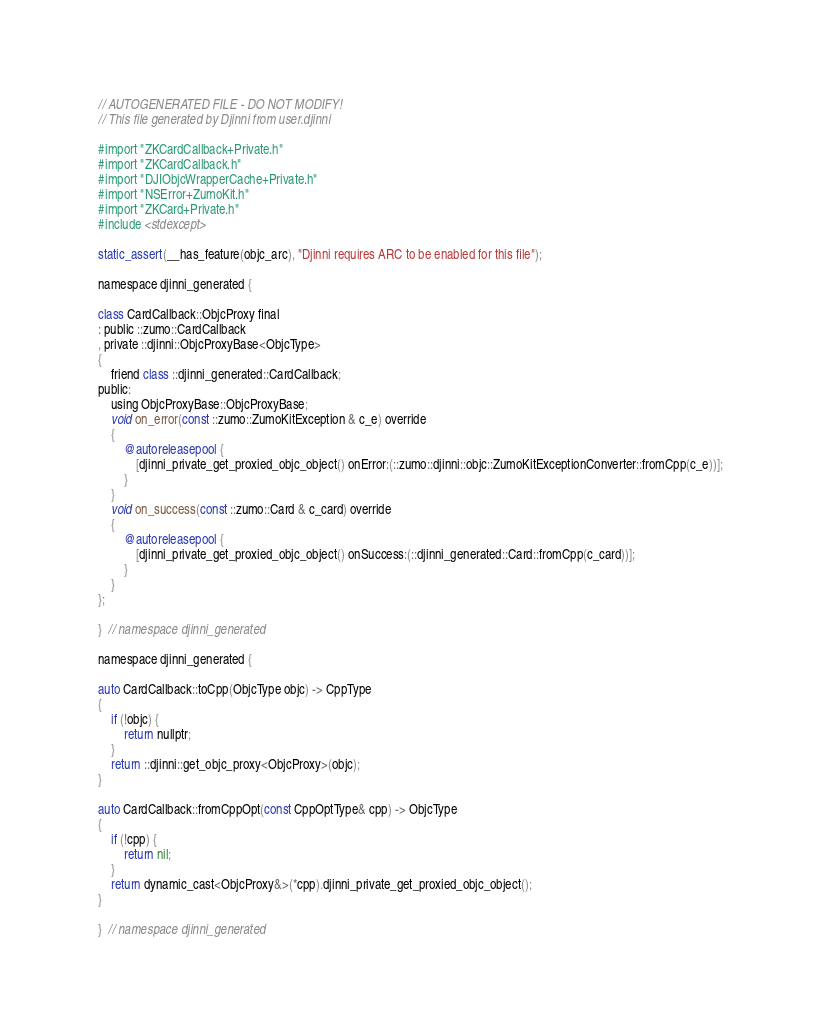Convert code to text. <code><loc_0><loc_0><loc_500><loc_500><_ObjectiveC_>// AUTOGENERATED FILE - DO NOT MODIFY!
// This file generated by Djinni from user.djinni

#import "ZKCardCallback+Private.h"
#import "ZKCardCallback.h"
#import "DJIObjcWrapperCache+Private.h"
#import "NSError+ZumoKit.h"
#import "ZKCard+Private.h"
#include <stdexcept>

static_assert(__has_feature(objc_arc), "Djinni requires ARC to be enabled for this file");

namespace djinni_generated {

class CardCallback::ObjcProxy final
: public ::zumo::CardCallback
, private ::djinni::ObjcProxyBase<ObjcType>
{
    friend class ::djinni_generated::CardCallback;
public:
    using ObjcProxyBase::ObjcProxyBase;
    void on_error(const ::zumo::ZumoKitException & c_e) override
    {
        @autoreleasepool {
            [djinni_private_get_proxied_objc_object() onError:(::zumo::djinni::objc::ZumoKitExceptionConverter::fromCpp(c_e))];
        }
    }
    void on_success(const ::zumo::Card & c_card) override
    {
        @autoreleasepool {
            [djinni_private_get_proxied_objc_object() onSuccess:(::djinni_generated::Card::fromCpp(c_card))];
        }
    }
};

}  // namespace djinni_generated

namespace djinni_generated {

auto CardCallback::toCpp(ObjcType objc) -> CppType
{
    if (!objc) {
        return nullptr;
    }
    return ::djinni::get_objc_proxy<ObjcProxy>(objc);
}

auto CardCallback::fromCppOpt(const CppOptType& cpp) -> ObjcType
{
    if (!cpp) {
        return nil;
    }
    return dynamic_cast<ObjcProxy&>(*cpp).djinni_private_get_proxied_objc_object();
}

}  // namespace djinni_generated
</code> 